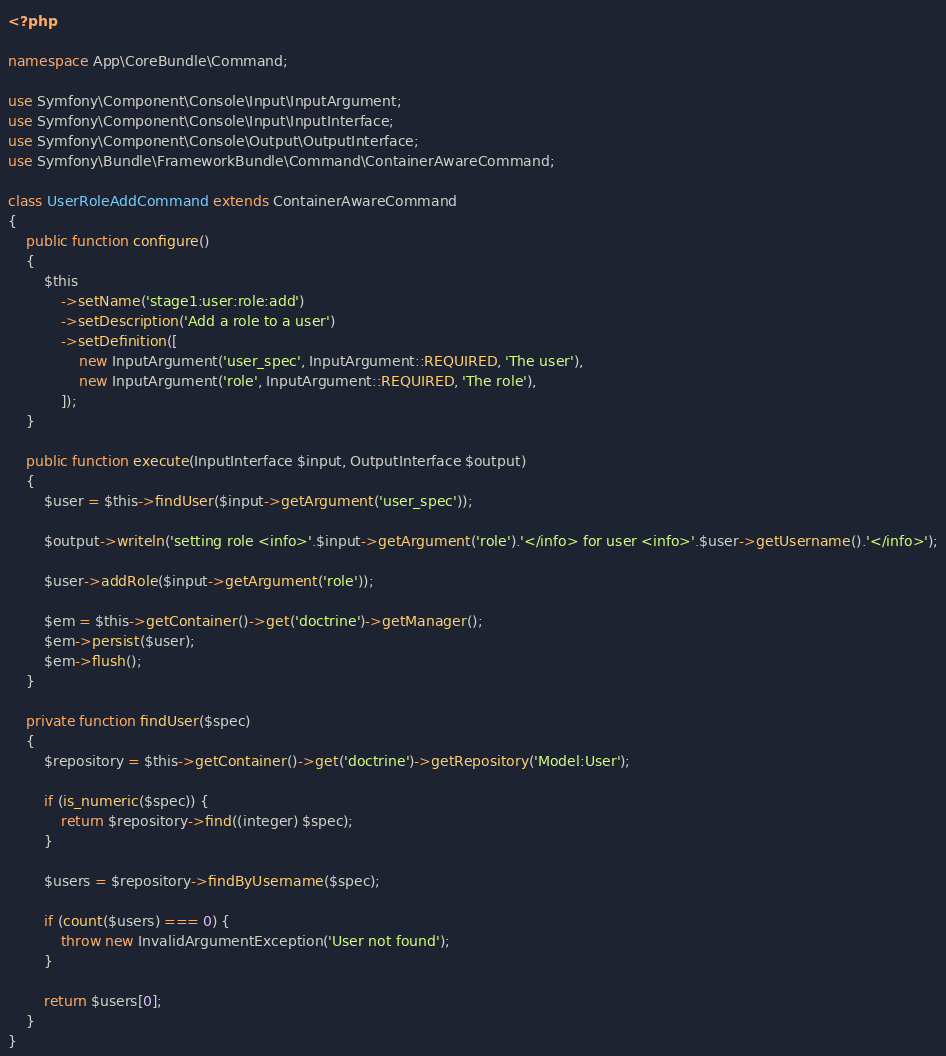<code> <loc_0><loc_0><loc_500><loc_500><_PHP_><?php

namespace App\CoreBundle\Command;

use Symfony\Component\Console\Input\InputArgument;
use Symfony\Component\Console\Input\InputInterface;
use Symfony\Component\Console\Output\OutputInterface;
use Symfony\Bundle\FrameworkBundle\Command\ContainerAwareCommand;

class UserRoleAddCommand extends ContainerAwareCommand
{
    public function configure()
    {
        $this
            ->setName('stage1:user:role:add')
            ->setDescription('Add a role to a user')
            ->setDefinition([
                new InputArgument('user_spec', InputArgument::REQUIRED, 'The user'),
                new InputArgument('role', InputArgument::REQUIRED, 'The role'),
            ]);
    }

    public function execute(InputInterface $input, OutputInterface $output)
    {
        $user = $this->findUser($input->getArgument('user_spec'));

        $output->writeln('setting role <info>'.$input->getArgument('role').'</info> for user <info>'.$user->getUsername().'</info>');

        $user->addRole($input->getArgument('role'));

        $em = $this->getContainer()->get('doctrine')->getManager();
        $em->persist($user);
        $em->flush();
    }

    private function findUser($spec)
    {
        $repository = $this->getContainer()->get('doctrine')->getRepository('Model:User');

        if (is_numeric($spec)) {
            return $repository->find((integer) $spec);
        }

        $users = $repository->findByUsername($spec);

        if (count($users) === 0) {
            throw new InvalidArgumentException('User not found');
        }

        return $users[0];
    }
}</code> 